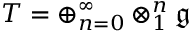<formula> <loc_0><loc_0><loc_500><loc_500>T = \oplus _ { n = 0 } ^ { \infty } \otimes _ { 1 } ^ { n } { \mathfrak { g } }</formula> 